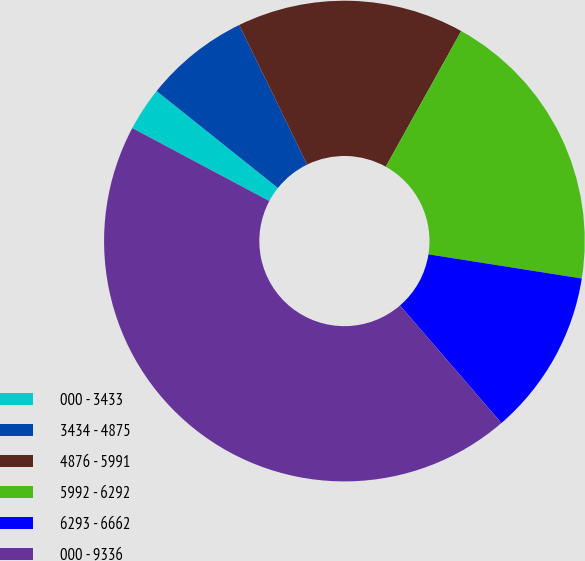Convert chart. <chart><loc_0><loc_0><loc_500><loc_500><pie_chart><fcel>000 - 3433<fcel>3434 - 4875<fcel>4876 - 5991<fcel>5992 - 6292<fcel>6293 - 6662<fcel>000 - 9336<nl><fcel>2.94%<fcel>7.06%<fcel>15.29%<fcel>19.41%<fcel>11.18%<fcel>44.12%<nl></chart> 